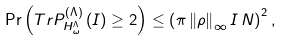<formula> <loc_0><loc_0><loc_500><loc_500>\Pr \left ( T r P _ { H _ { \omega } ^ { \Lambda } } ^ { ( \Lambda ) } \left ( I \right ) \geq 2 \right ) \leq \left ( \pi \left \| \rho \right \| _ { \infty } I \, N \right ) ^ { 2 } ,</formula> 